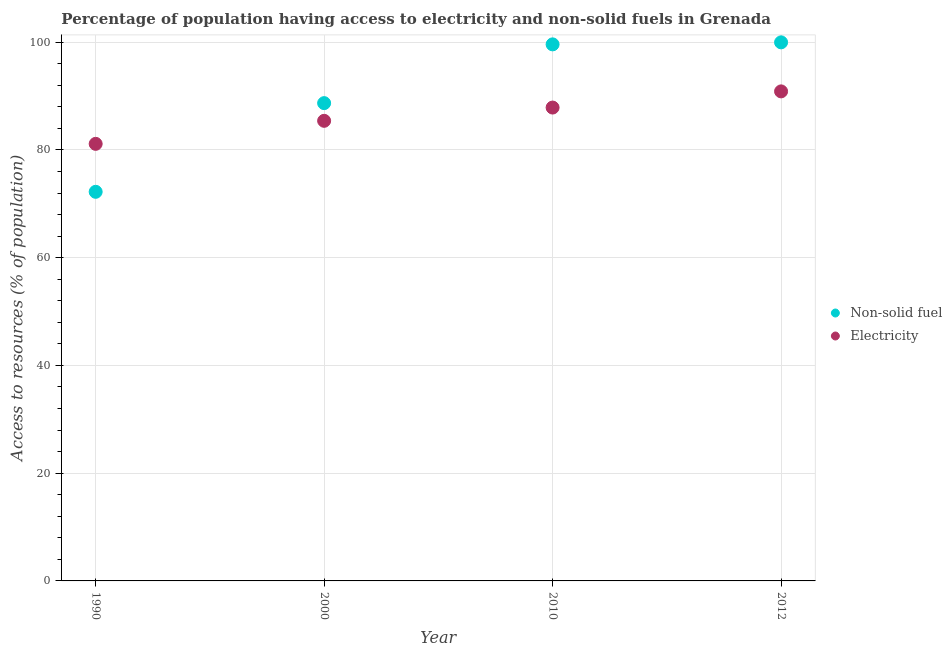What is the percentage of population having access to electricity in 2012?
Provide a succinct answer. 90.88. Across all years, what is the maximum percentage of population having access to non-solid fuel?
Ensure brevity in your answer.  99.98. Across all years, what is the minimum percentage of population having access to electricity?
Your response must be concise. 81.14. In which year was the percentage of population having access to non-solid fuel maximum?
Offer a very short reply. 2012. In which year was the percentage of population having access to non-solid fuel minimum?
Provide a short and direct response. 1990. What is the total percentage of population having access to electricity in the graph?
Make the answer very short. 345.3. What is the difference between the percentage of population having access to non-solid fuel in 2000 and that in 2012?
Your response must be concise. -11.28. What is the difference between the percentage of population having access to electricity in 2012 and the percentage of population having access to non-solid fuel in 2000?
Make the answer very short. 2.18. What is the average percentage of population having access to electricity per year?
Offer a very short reply. 86.32. In the year 1990, what is the difference between the percentage of population having access to non-solid fuel and percentage of population having access to electricity?
Give a very brief answer. -8.9. In how many years, is the percentage of population having access to non-solid fuel greater than 56 %?
Your response must be concise. 4. What is the ratio of the percentage of population having access to electricity in 1990 to that in 2012?
Provide a succinct answer. 0.89. What is the difference between the highest and the second highest percentage of population having access to non-solid fuel?
Offer a very short reply. 0.37. What is the difference between the highest and the lowest percentage of population having access to non-solid fuel?
Your response must be concise. 27.75. Is the percentage of population having access to electricity strictly less than the percentage of population having access to non-solid fuel over the years?
Offer a terse response. No. How many dotlines are there?
Make the answer very short. 2. How many years are there in the graph?
Provide a succinct answer. 4. What is the difference between two consecutive major ticks on the Y-axis?
Your response must be concise. 20. Are the values on the major ticks of Y-axis written in scientific E-notation?
Provide a succinct answer. No. Where does the legend appear in the graph?
Provide a short and direct response. Center right. How are the legend labels stacked?
Offer a very short reply. Vertical. What is the title of the graph?
Your response must be concise. Percentage of population having access to electricity and non-solid fuels in Grenada. Does "Methane emissions" appear as one of the legend labels in the graph?
Give a very brief answer. No. What is the label or title of the Y-axis?
Give a very brief answer. Access to resources (% of population). What is the Access to resources (% of population) of Non-solid fuel in 1990?
Give a very brief answer. 72.23. What is the Access to resources (% of population) of Electricity in 1990?
Offer a very short reply. 81.14. What is the Access to resources (% of population) in Non-solid fuel in 2000?
Make the answer very short. 88.69. What is the Access to resources (% of population) of Electricity in 2000?
Give a very brief answer. 85.41. What is the Access to resources (% of population) of Non-solid fuel in 2010?
Keep it short and to the point. 99.6. What is the Access to resources (% of population) of Electricity in 2010?
Your response must be concise. 87.87. What is the Access to resources (% of population) of Non-solid fuel in 2012?
Make the answer very short. 99.98. What is the Access to resources (% of population) in Electricity in 2012?
Your answer should be very brief. 90.88. Across all years, what is the maximum Access to resources (% of population) of Non-solid fuel?
Make the answer very short. 99.98. Across all years, what is the maximum Access to resources (% of population) in Electricity?
Ensure brevity in your answer.  90.88. Across all years, what is the minimum Access to resources (% of population) in Non-solid fuel?
Your answer should be very brief. 72.23. Across all years, what is the minimum Access to resources (% of population) in Electricity?
Give a very brief answer. 81.14. What is the total Access to resources (% of population) of Non-solid fuel in the graph?
Keep it short and to the point. 360.51. What is the total Access to resources (% of population) in Electricity in the graph?
Your answer should be compact. 345.3. What is the difference between the Access to resources (% of population) in Non-solid fuel in 1990 and that in 2000?
Offer a terse response. -16.46. What is the difference between the Access to resources (% of population) in Electricity in 1990 and that in 2000?
Keep it short and to the point. -4.28. What is the difference between the Access to resources (% of population) of Non-solid fuel in 1990 and that in 2010?
Offer a terse response. -27.37. What is the difference between the Access to resources (% of population) in Electricity in 1990 and that in 2010?
Offer a terse response. -6.74. What is the difference between the Access to resources (% of population) in Non-solid fuel in 1990 and that in 2012?
Offer a very short reply. -27.75. What is the difference between the Access to resources (% of population) of Electricity in 1990 and that in 2012?
Your response must be concise. -9.74. What is the difference between the Access to resources (% of population) in Non-solid fuel in 2000 and that in 2010?
Keep it short and to the point. -10.91. What is the difference between the Access to resources (% of population) of Electricity in 2000 and that in 2010?
Make the answer very short. -2.46. What is the difference between the Access to resources (% of population) of Non-solid fuel in 2000 and that in 2012?
Your answer should be compact. -11.28. What is the difference between the Access to resources (% of population) of Electricity in 2000 and that in 2012?
Make the answer very short. -5.46. What is the difference between the Access to resources (% of population) in Non-solid fuel in 2010 and that in 2012?
Offer a very short reply. -0.37. What is the difference between the Access to resources (% of population) in Electricity in 2010 and that in 2012?
Provide a short and direct response. -3. What is the difference between the Access to resources (% of population) of Non-solid fuel in 1990 and the Access to resources (% of population) of Electricity in 2000?
Ensure brevity in your answer.  -13.18. What is the difference between the Access to resources (% of population) of Non-solid fuel in 1990 and the Access to resources (% of population) of Electricity in 2010?
Give a very brief answer. -15.64. What is the difference between the Access to resources (% of population) of Non-solid fuel in 1990 and the Access to resources (% of population) of Electricity in 2012?
Your response must be concise. -18.64. What is the difference between the Access to resources (% of population) in Non-solid fuel in 2000 and the Access to resources (% of population) in Electricity in 2010?
Keep it short and to the point. 0.82. What is the difference between the Access to resources (% of population) in Non-solid fuel in 2000 and the Access to resources (% of population) in Electricity in 2012?
Offer a terse response. -2.18. What is the difference between the Access to resources (% of population) in Non-solid fuel in 2010 and the Access to resources (% of population) in Electricity in 2012?
Keep it short and to the point. 8.73. What is the average Access to resources (% of population) in Non-solid fuel per year?
Your response must be concise. 90.13. What is the average Access to resources (% of population) in Electricity per year?
Keep it short and to the point. 86.32. In the year 1990, what is the difference between the Access to resources (% of population) of Non-solid fuel and Access to resources (% of population) of Electricity?
Offer a terse response. -8.9. In the year 2000, what is the difference between the Access to resources (% of population) of Non-solid fuel and Access to resources (% of population) of Electricity?
Your answer should be compact. 3.28. In the year 2010, what is the difference between the Access to resources (% of population) of Non-solid fuel and Access to resources (% of population) of Electricity?
Make the answer very short. 11.73. In the year 2012, what is the difference between the Access to resources (% of population) of Non-solid fuel and Access to resources (% of population) of Electricity?
Provide a succinct answer. 9.1. What is the ratio of the Access to resources (% of population) of Non-solid fuel in 1990 to that in 2000?
Provide a succinct answer. 0.81. What is the ratio of the Access to resources (% of population) in Electricity in 1990 to that in 2000?
Keep it short and to the point. 0.95. What is the ratio of the Access to resources (% of population) in Non-solid fuel in 1990 to that in 2010?
Your answer should be compact. 0.73. What is the ratio of the Access to resources (% of population) of Electricity in 1990 to that in 2010?
Offer a terse response. 0.92. What is the ratio of the Access to resources (% of population) of Non-solid fuel in 1990 to that in 2012?
Offer a terse response. 0.72. What is the ratio of the Access to resources (% of population) in Electricity in 1990 to that in 2012?
Provide a short and direct response. 0.89. What is the ratio of the Access to resources (% of population) of Non-solid fuel in 2000 to that in 2010?
Your answer should be very brief. 0.89. What is the ratio of the Access to resources (% of population) in Electricity in 2000 to that in 2010?
Ensure brevity in your answer.  0.97. What is the ratio of the Access to resources (% of population) in Non-solid fuel in 2000 to that in 2012?
Offer a very short reply. 0.89. What is the ratio of the Access to resources (% of population) in Electricity in 2000 to that in 2012?
Make the answer very short. 0.94. What is the ratio of the Access to resources (% of population) of Non-solid fuel in 2010 to that in 2012?
Offer a terse response. 1. What is the ratio of the Access to resources (% of population) of Electricity in 2010 to that in 2012?
Your response must be concise. 0.97. What is the difference between the highest and the second highest Access to resources (% of population) in Non-solid fuel?
Offer a terse response. 0.37. What is the difference between the highest and the second highest Access to resources (% of population) of Electricity?
Offer a very short reply. 3. What is the difference between the highest and the lowest Access to resources (% of population) in Non-solid fuel?
Keep it short and to the point. 27.75. What is the difference between the highest and the lowest Access to resources (% of population) in Electricity?
Provide a succinct answer. 9.74. 